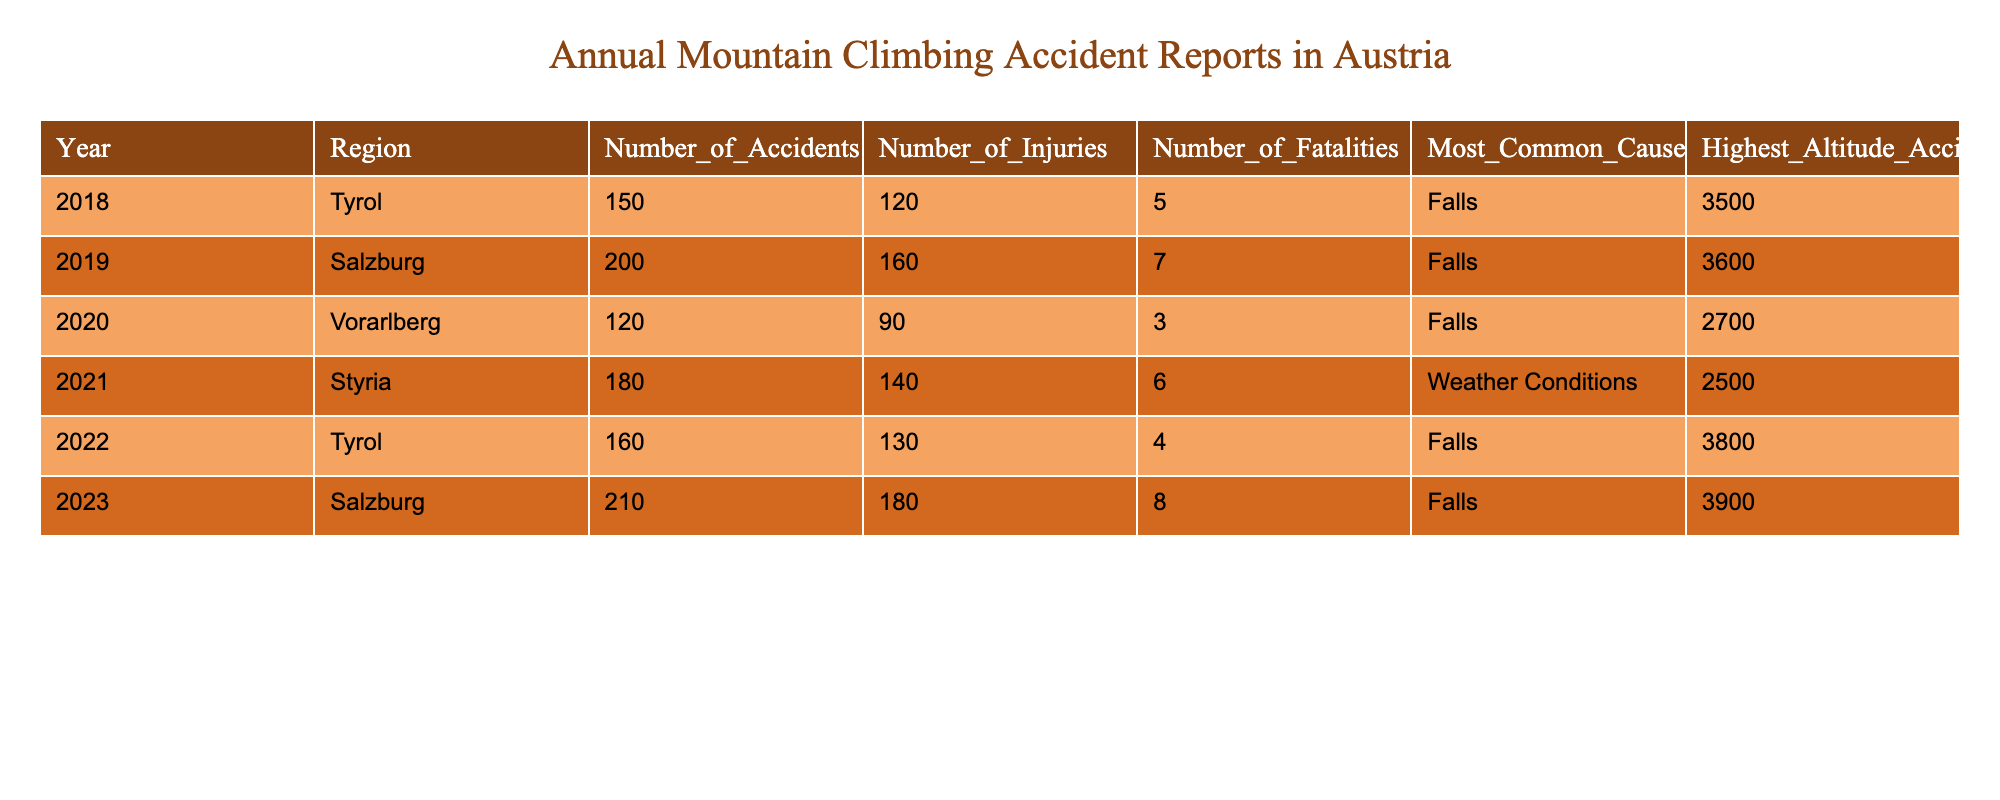What was the total number of accidents reported in Tyrol over the years? The number of accidents in Tyrol for the years 2018 and 2022 are 150 and 160, respectively. Adding these numbers gives 150 + 160 = 310.
Answer: 310 Which region had the highest number of fatalities in a single year? The most fatalities were reported in 2019 in Salzburg with 7 fatalities. This is the highest among all regions for the years provided.
Answer: Salzburg What was the average number of injuries across all regions in 2023? The injuries recorded in 2023 were 180 in Salzburg. Since there's only one entry for 2023, the average is simply 180/1 = 180.
Answer: 180 Which year had the most accidents, and what was the most common cause in that year? The year with the most accidents was 2019 with 200 accidents, and the most common cause was Falls.
Answer: 2019; Falls What percentage of accidents in Styria led to fatalities in 2021? In 2021, there were 180 accidents and 6 fatalities. To find the percentage, we calculate (6 / 180) * 100 which equals 3.33%.
Answer: 3.33% Is the most common cause of accidents always Falls? Falls were the most common cause in 2018, 2019, 2020, 2022, and 2023. However, in 2021, Weather Conditions were the most common cause. Thus, the statement is false.
Answer: No What is the difference in the number of injuries between Salzburg in 2019 and Tyrol in 2022? Salzburg had 160 injuries in 2019, while Tyrol had 130 injuries in 2022. The difference is 160 - 130 = 30.
Answer: 30 Considering the highest altitude of accidents, which year had the highest altitude and what was the most common cause? The year 2023 had the highest altitude at 3900 meters with the most common cause being Falls.
Answer: 2023; Falls What is the total number of fatalities reported across all years? The fatalities reported are 5 (2018) + 7 (2019) + 3 (2020) + 6 (2021) + 4 (2022) + 8 (2023) = 33.
Answer: 33 What trend can be identified in the number of accidents from 2018 to 2023? The number of accidents increased from 150 in 2018 to 210 in 2023, indicating a rising trend in accidents over the years.
Answer: Increasing trend 